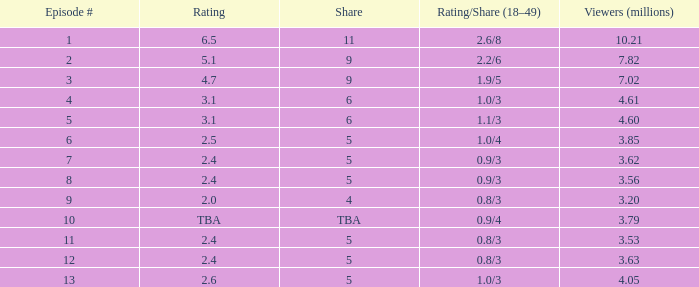What is the evaluation/share for episode 13? 1.0/3. 